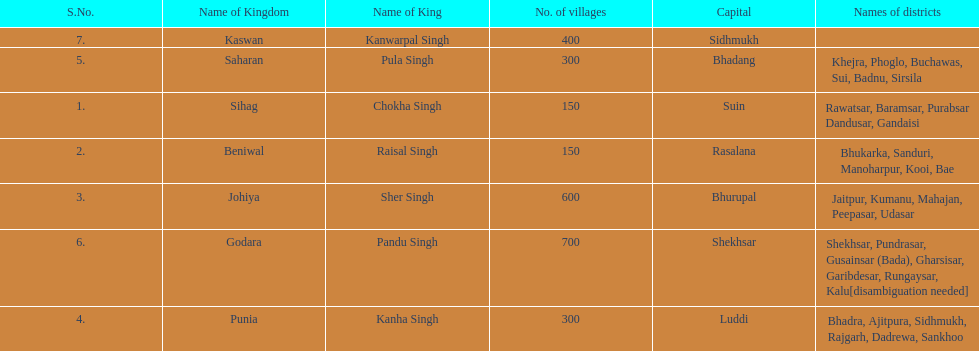Which kingdom has the most villages? Godara. 